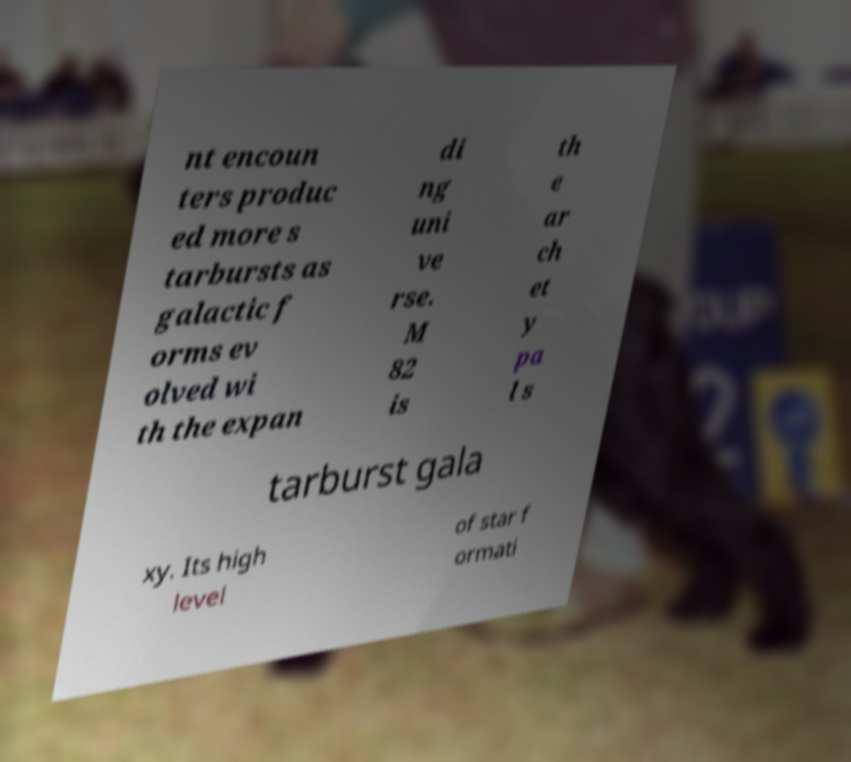For documentation purposes, I need the text within this image transcribed. Could you provide that? nt encoun ters produc ed more s tarbursts as galactic f orms ev olved wi th the expan di ng uni ve rse. M 82 is th e ar ch et y pa l s tarburst gala xy. Its high level of star f ormati 